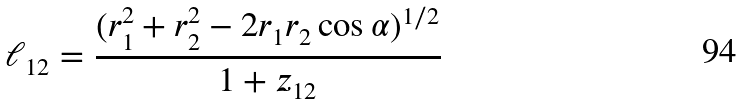Convert formula to latex. <formula><loc_0><loc_0><loc_500><loc_500>\ell _ { 1 2 } = \frac { ( r _ { 1 } ^ { 2 } + r _ { 2 } ^ { 2 } - 2 r _ { 1 } r _ { 2 } \cos \alpha ) ^ { 1 / 2 } } { 1 + z _ { 1 2 } }</formula> 